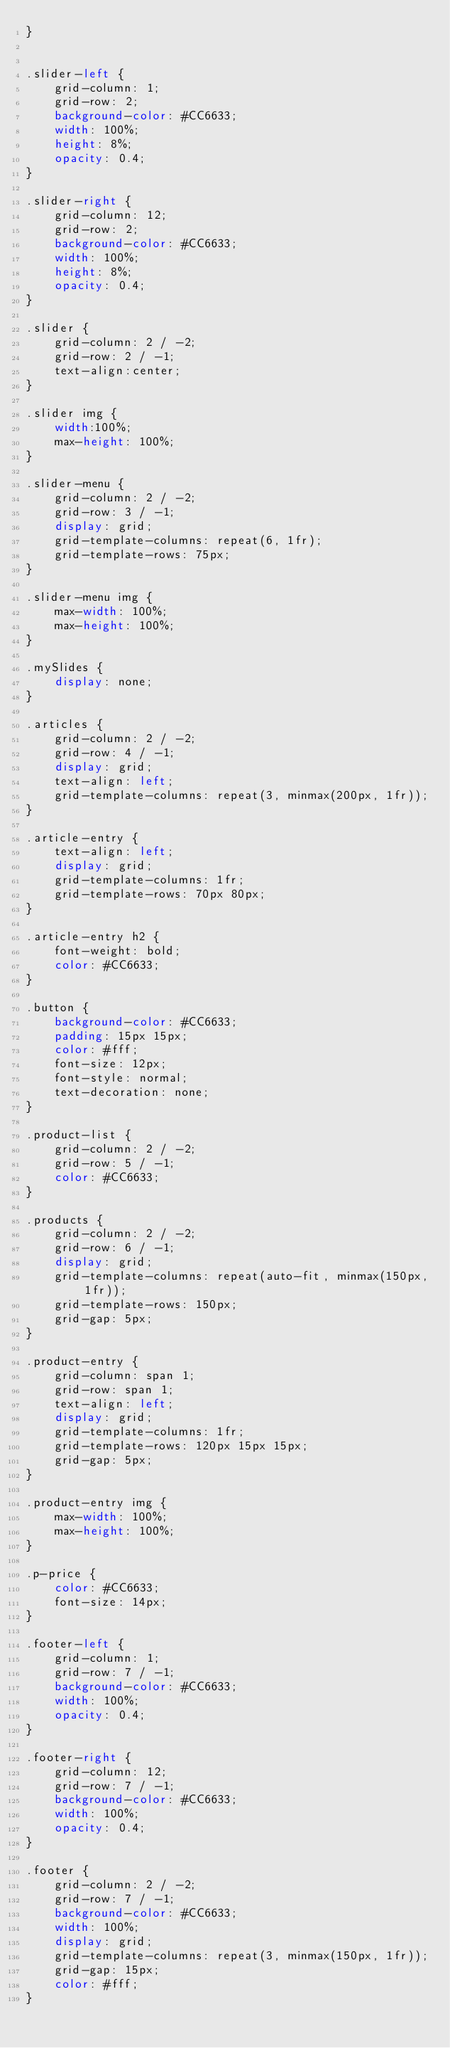Convert code to text. <code><loc_0><loc_0><loc_500><loc_500><_CSS_>}


.slider-left {
    grid-column: 1;
    grid-row: 2;
    background-color: #CC6633;
    width: 100%;
    height: 8%;
    opacity: 0.4;
}

.slider-right {
    grid-column: 12;
    grid-row: 2;
    background-color: #CC6633;
    width: 100%;
    height: 8%;
    opacity: 0.4;
}

.slider {
    grid-column: 2 / -2;
    grid-row: 2 / -1;
    text-align:center;
}

.slider img {
    width:100%;
    max-height: 100%;
}

.slider-menu {
    grid-column: 2 / -2;
    grid-row: 3 / -1;
    display: grid;
    grid-template-columns: repeat(6, 1fr);
    grid-template-rows: 75px;
}

.slider-menu img {
    max-width: 100%;
    max-height: 100%;
}

.mySlides {
    display: none;
}

.articles {
    grid-column: 2 / -2;
    grid-row: 4 / -1;
    display: grid;
    text-align: left;
    grid-template-columns: repeat(3, minmax(200px, 1fr));
}

.article-entry {
    text-align: left;
    display: grid;
    grid-template-columns: 1fr;
    grid-template-rows: 70px 80px;
}

.article-entry h2 {
    font-weight: bold;
    color: #CC6633;
}

.button {
    background-color: #CC6633;
    padding: 15px 15px;
    color: #fff;
    font-size: 12px;
    font-style: normal;
    text-decoration: none;
}

.product-list {
    grid-column: 2 / -2;
    grid-row: 5 / -1;
    color: #CC6633;
}

.products {
    grid-column: 2 / -2;
    grid-row: 6 / -1;
    display: grid;
    grid-template-columns: repeat(auto-fit, minmax(150px, 1fr));
    grid-template-rows: 150px;
    grid-gap: 5px;
}

.product-entry {
    grid-column: span 1;
    grid-row: span 1;
    text-align: left;
    display: grid;
    grid-template-columns: 1fr;
    grid-template-rows: 120px 15px 15px;
    grid-gap: 5px;
}

.product-entry img {
    max-width: 100%;
    max-height: 100%;
}

.p-price {
    color: #CC6633;
    font-size: 14px;
}

.footer-left {
    grid-column: 1;
    grid-row: 7 / -1;
    background-color: #CC6633;
    width: 100%;
    opacity: 0.4;
}

.footer-right {
    grid-column: 12;
    grid-row: 7 / -1;
    background-color: #CC6633;
    width: 100%;
    opacity: 0.4;
}

.footer {
    grid-column: 2 / -2;
    grid-row: 7 / -1;
    background-color: #CC6633;
    width: 100%;
    display: grid;
    grid-template-columns: repeat(3, minmax(150px, 1fr));
    grid-gap: 15px;
    color: #fff;
}
</code> 